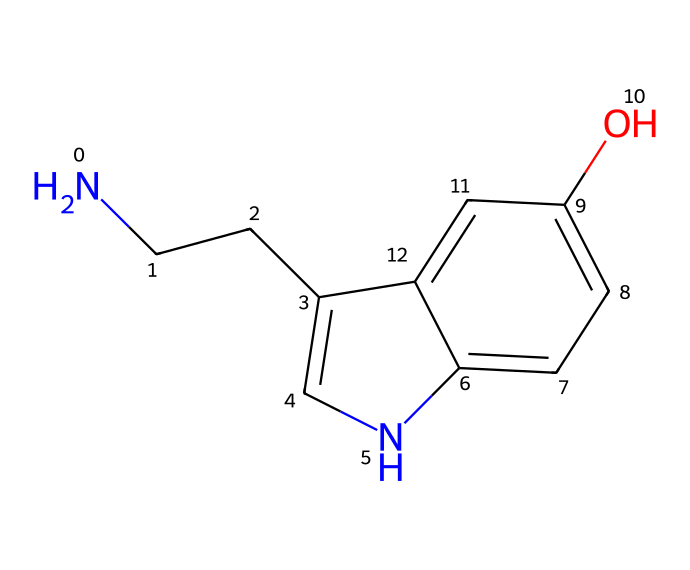What is the number of carbon atoms in serotonin? By analyzing the SMILES representation, I can identify the carbon atoms represented in the structure, each denoted by a 'C'. Counting all distinct 'C' within the molecular structure yields a total of 10 carbon atoms.
Answer: 10 How many rings are present in serotonin? In the SMILES representation, I can identify ring structures by looking for the numeric indicators which denote the start and end of a ring. The numbers '1' and '2' in the SMILES denote two distinct rings in the structure, confirming there are two rings present.
Answer: 2 What type of bonding is primarily associated with the nitrogen atom in serotonin? The nitrogen atom in serotonin is connected to two carbon atoms, which indicates it primarily engages in covalent bonding. Covalent bonds involve shared electron pairs between atoms.
Answer: covalent Which functional group is indicated by the hydroxyl group (−OH) in serotonin? The hydroxyl group mentioned here is indicated within the structure where an oxygen atom is connected to a hydrogen atom (−OH), characterizing it as an alcohol. This specific configuration performs a significant role in the chemical's properties and interactions.
Answer: alcohol Does serotonin have any double bonds in its structure? Looking at the SMILES representation, I can see that double bonds are represented as interconnections without an explicit numeral; however, the presence of double bonds can be inferred from the connectivity and hybridization of atoms like carbon and nitrogen. Upon examination, serotonin indeed has two double bonds in its structure.
Answer: yes What is the role of the nitrogen atom in serotonin’s function as a neurotransmitter? The nitrogen atom in neurotransmitters, including serotonin, often plays a critical role in forming ionic interactions with receptors and facilitating the neurotransmitter action by enabling it to bind effectively at receptor sites. Thus, the nitrogen is pivotal in functionality and morphology.
Answer: binding 